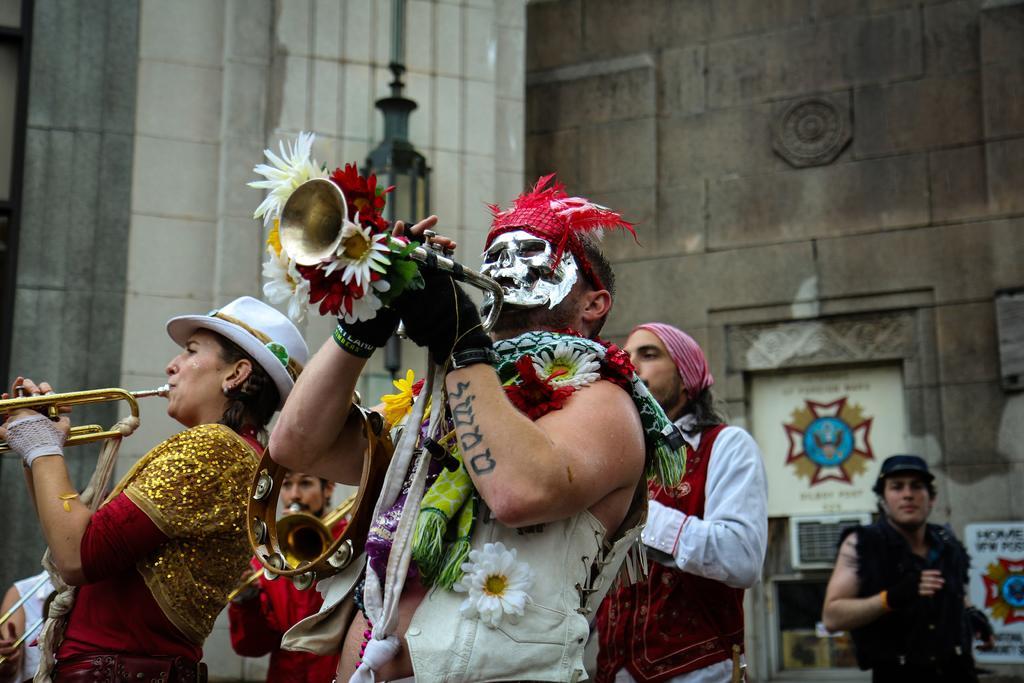In one or two sentences, can you explain what this image depicts? In this image we can see a few people, some of them are playing musical instruments, there are flowers, a light pole, also we can see the wall. 